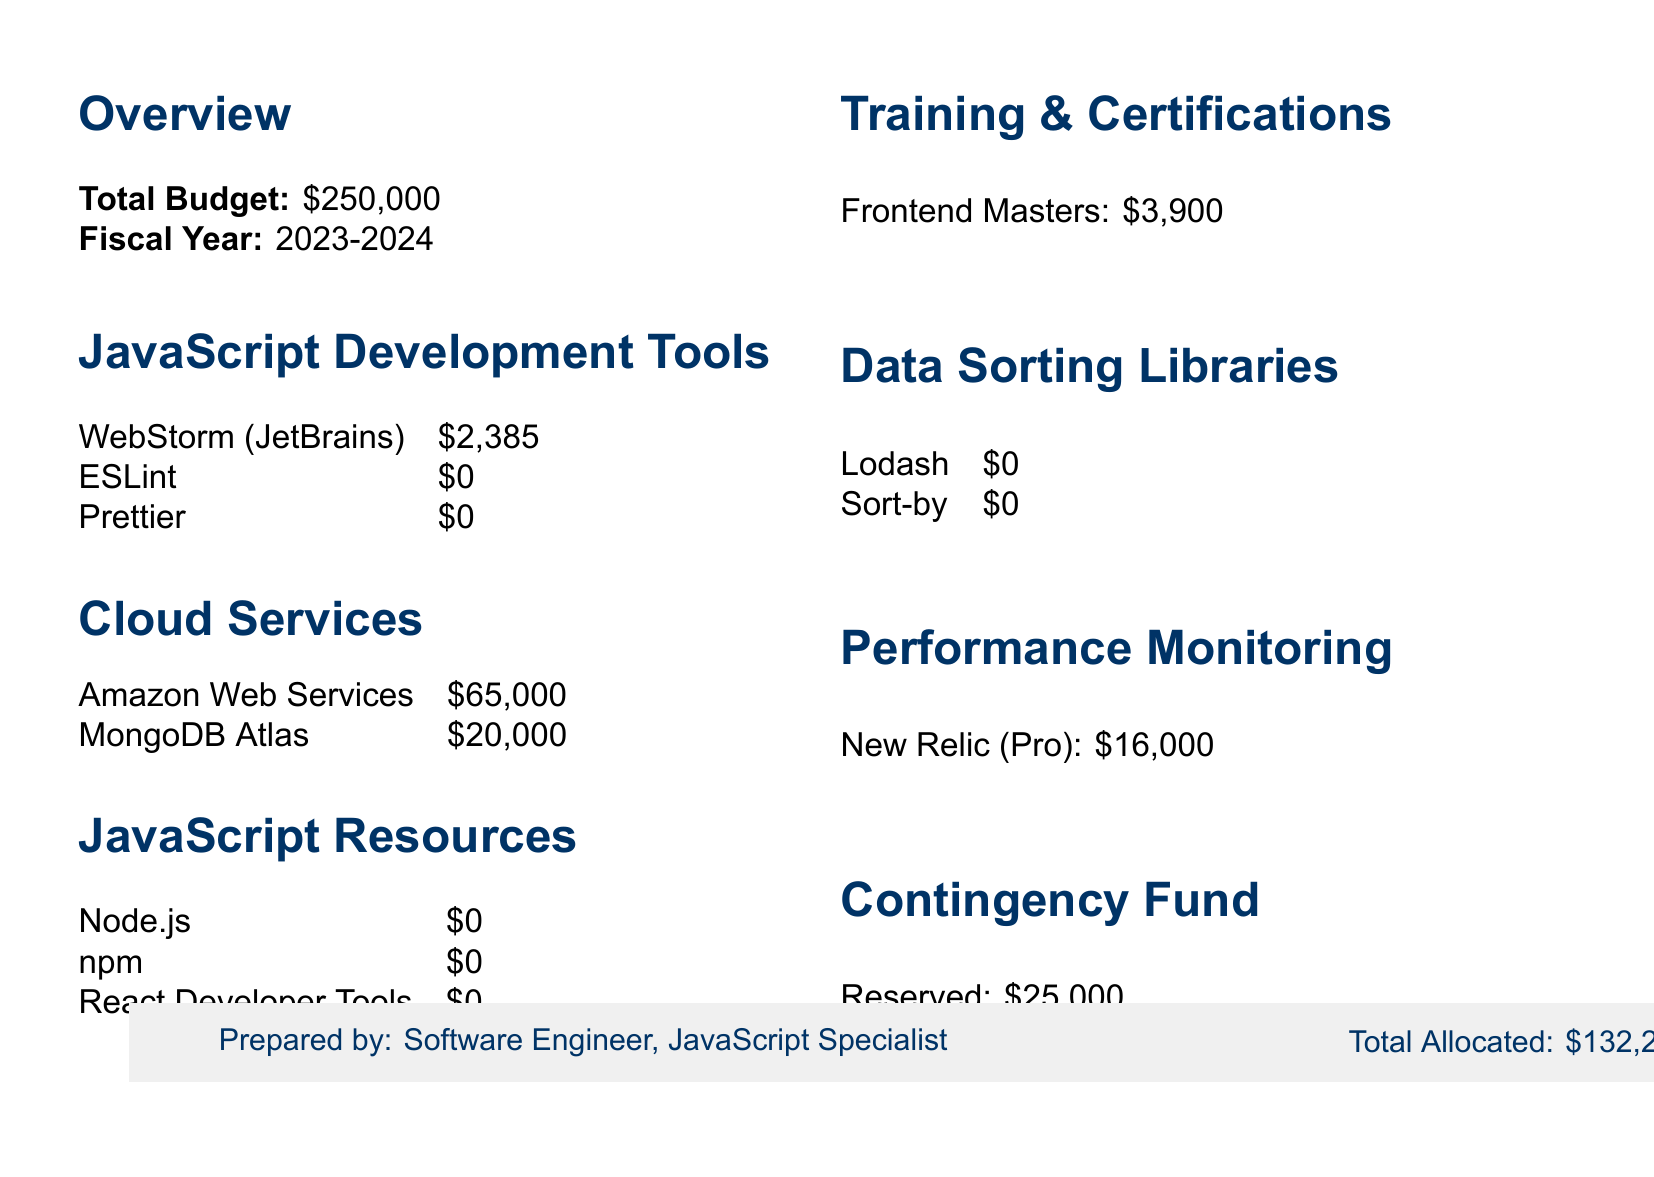what is the total budget? The total budget is highlighted in the overview section of the document.
Answer: $250,000 how many licenses are allocated for WebStorm? The document specifies the total licenses allocated for WebStorm in the JavaScript Development Tools section.
Answer: 15 what is the budget allocation for AWS? This information is found under the cloud services section, where AWS is listed with its budget allocation.
Answer: $65,000 how much is allocated for training and certifications? The allocation for training and certifications is mentioned under a dedicated section, giving the specific budget amount.
Answer: $3,900 what is the allocated amount for the contingency fund? The document describes the contingency fund and the amount reserved for unexpected expenses.
Answer: $25,000 what are the total allocated resources for JavaScript-specific tools? This requires summing up the budget allocations for JavaScript-related resources listed in the document.
Answer: $0 how much is the budget allocation for New Relic? The budget allocation for New Relic is specified in the performance monitoring section of the document.
Answer: $16,000 what is the annual subscription cost per user for Frontend Masters? This detail is provided within the training and certifications section, indicating the cost per user for the subscription.
Answer: $390 per user which open-source tools have a budget allocation of zero? This question prompts looking at the JavaScript development tools and data sorting libraries sections for tools with no allocated budget.
Answer: ESLint, Prettier, Node.js, npm, React Developer Tools, Lodash, Sort-by 